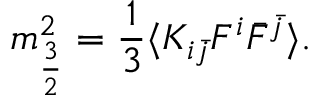Convert formula to latex. <formula><loc_0><loc_0><loc_500><loc_500>m _ { \frac { 3 } { 2 } } ^ { 2 } = \frac { 1 } { 3 } \langle K _ { i \bar { j } } F ^ { i } \bar { F } ^ { \bar { j } } \rangle .</formula> 